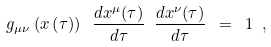Convert formula to latex. <formula><loc_0><loc_0><loc_500><loc_500>g _ { \mu \nu } \left ( x \left ( \tau \right ) \right ) \ \frac { d x ^ { \mu } ( \tau ) } { d \tau } \ \frac { d x ^ { \nu } ( \tau ) } { d \tau } \ = \ 1 \ ,</formula> 